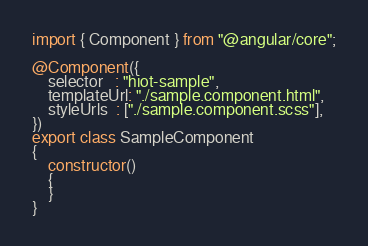<code> <loc_0><loc_0><loc_500><loc_500><_TypeScript_>import { Component } from "@angular/core";

@Component({
    selector   : "hiot-sample",
    templateUrl: "./sample.component.html",
    styleUrls  : ["./sample.component.scss"],
})
export class SampleComponent
{
    constructor()
    {
    }
}
</code> 